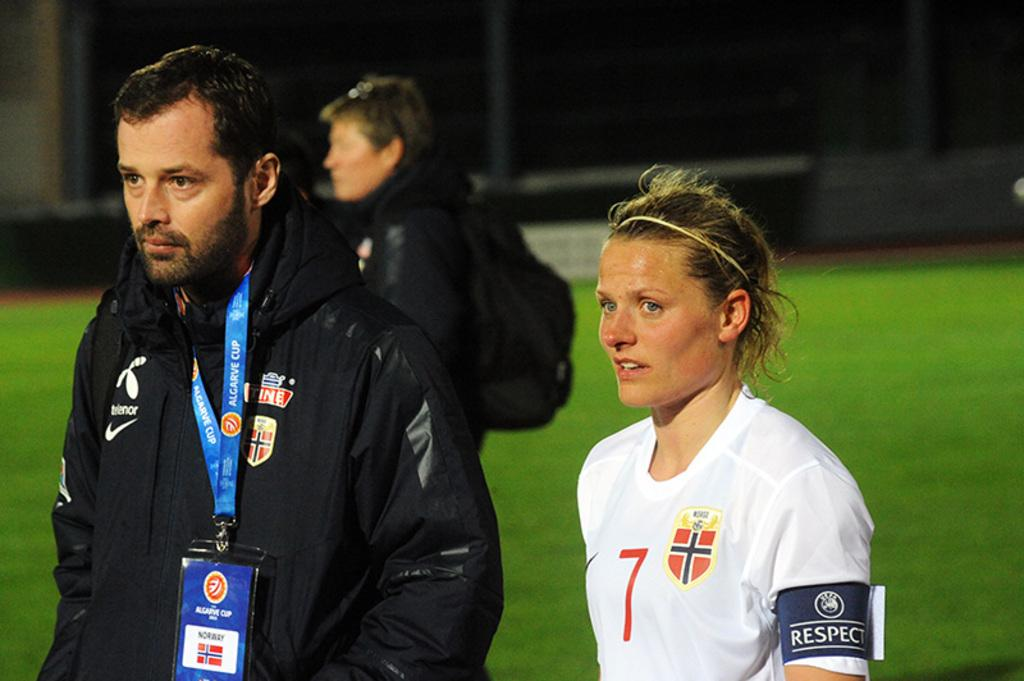<image>
Describe the image concisely. the number 7 is on the white shirt of the lady 